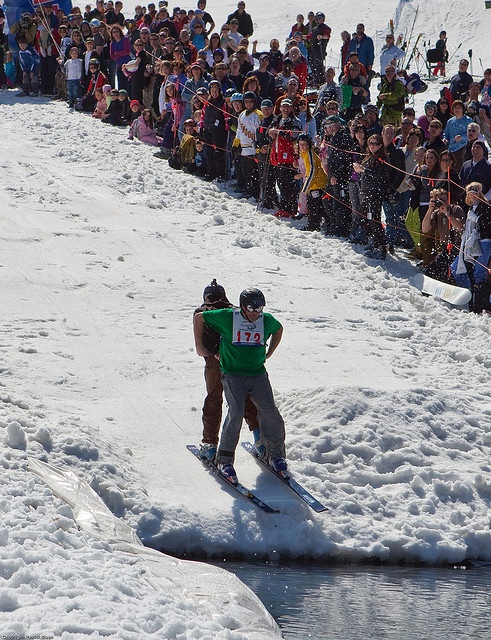Describe the objects in this image and their specific colors. I can see people in darkgray, black, gray, lightgray, and maroon tones, people in darkgray, black, gray, and darkgreen tones, people in darkgray, black, gray, and lightgray tones, people in darkgray, black, gray, and maroon tones, and people in darkgray, black, gray, and maroon tones in this image. 